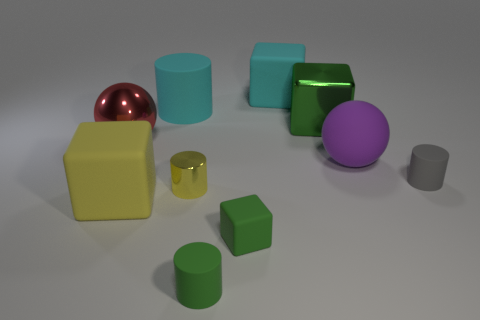Subtract all purple balls. How many green cubes are left? 2 Subtract all green metallic cubes. How many cubes are left? 3 Subtract all cyan blocks. How many blocks are left? 3 Subtract all cylinders. How many objects are left? 6 Subtract all green cylinders. Subtract all purple spheres. How many cylinders are left? 3 Add 6 green metal blocks. How many green metal blocks exist? 7 Subtract 0 gray cubes. How many objects are left? 10 Subtract all large brown shiny cubes. Subtract all big purple things. How many objects are left? 9 Add 2 cyan matte objects. How many cyan matte objects are left? 4 